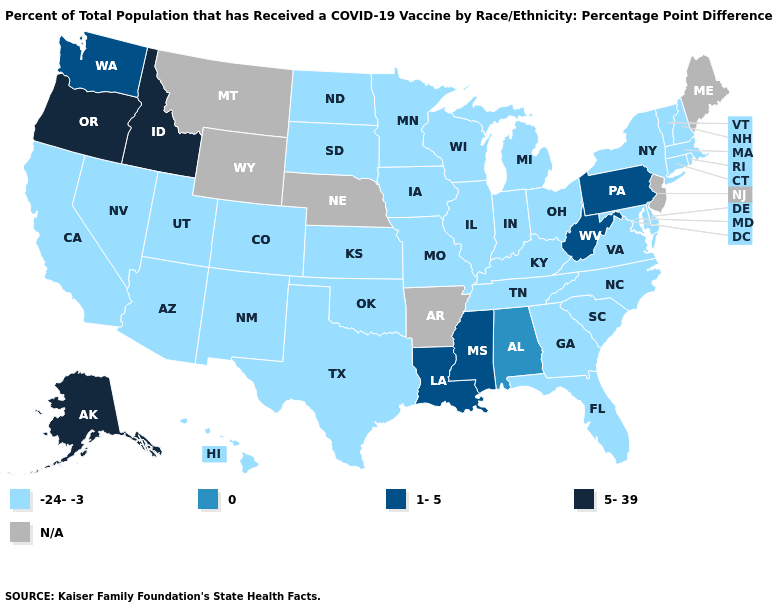Which states have the highest value in the USA?
Quick response, please. Alaska, Idaho, Oregon. Name the states that have a value in the range N/A?
Concise answer only. Arkansas, Maine, Montana, Nebraska, New Jersey, Wyoming. What is the value of Tennessee?
Answer briefly. -24--3. Among the states that border Kentucky , which have the lowest value?
Concise answer only. Illinois, Indiana, Missouri, Ohio, Tennessee, Virginia. Does Connecticut have the highest value in the Northeast?
Answer briefly. No. What is the highest value in states that border Rhode Island?
Keep it brief. -24--3. What is the value of New Hampshire?
Give a very brief answer. -24--3. Name the states that have a value in the range 5-39?
Give a very brief answer. Alaska, Idaho, Oregon. Among the states that border Oregon , does California have the lowest value?
Write a very short answer. Yes. What is the lowest value in the USA?
Write a very short answer. -24--3. What is the lowest value in the USA?
Give a very brief answer. -24--3. Does the map have missing data?
Concise answer only. Yes. Does Idaho have the lowest value in the West?
Be succinct. No. Does Kansas have the lowest value in the USA?
Concise answer only. Yes. Which states hav the highest value in the MidWest?
Give a very brief answer. Illinois, Indiana, Iowa, Kansas, Michigan, Minnesota, Missouri, North Dakota, Ohio, South Dakota, Wisconsin. 